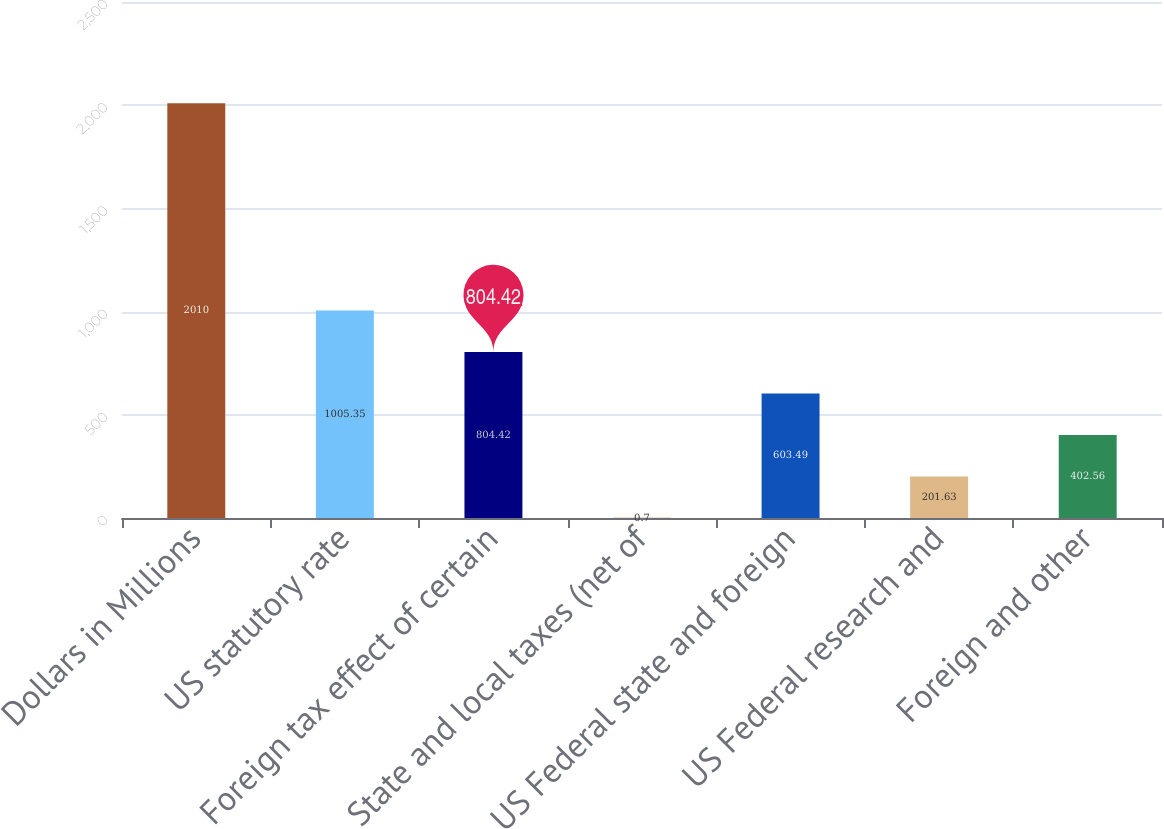Convert chart to OTSL. <chart><loc_0><loc_0><loc_500><loc_500><bar_chart><fcel>Dollars in Millions<fcel>US statutory rate<fcel>Foreign tax effect of certain<fcel>State and local taxes (net of<fcel>US Federal state and foreign<fcel>US Federal research and<fcel>Foreign and other<nl><fcel>2010<fcel>1005.35<fcel>804.42<fcel>0.7<fcel>603.49<fcel>201.63<fcel>402.56<nl></chart> 